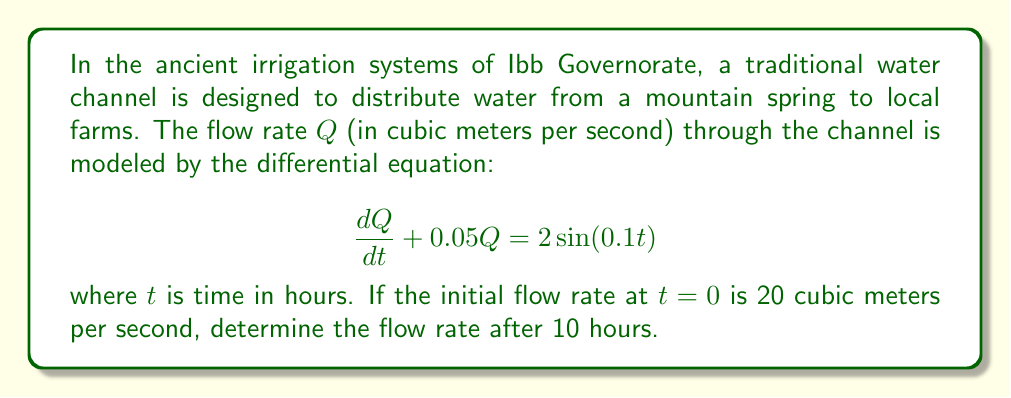Show me your answer to this math problem. To solve this first-order linear differential equation, we'll use the integrating factor method:

1) The equation is in the form $\frac{dQ}{dt} + PQ = f(t)$, where $P = 0.05$ and $f(t) = 2\sin(0.1t)$.

2) The integrating factor is $\mu(t) = e^{\int P dt} = e^{0.05t}$.

3) Multiply both sides of the equation by $\mu(t)$:

   $$e^{0.05t}\frac{dQ}{dt} + 0.05e^{0.05t}Q = 2e^{0.05t}\sin(0.1t)$$

4) The left side is now the derivative of $e^{0.05t}Q$:

   $$\frac{d}{dt}(e^{0.05t}Q) = 2e^{0.05t}\sin(0.1t)$$

5) Integrate both sides:

   $$e^{0.05t}Q = \int 2e^{0.05t}\sin(0.1t)dt$$

6) Solve the integral using integration by parts:

   $$e^{0.05t}Q = 2e^{0.05t}(\frac{5\sin(0.1t) - 10\cos(0.1t)}{1.25}) + C$$

7) Divide both sides by $e^{0.05t}$:

   $$Q = \frac{10(\sin(0.1t) - 2\cos(0.1t))}{1.25} + Ce^{-0.05t}$$

8) Use the initial condition $Q(0) = 20$ to find $C$:

   $$20 = \frac{10(-2)}{1.25} + C$$
   $$C = 20 + 16 = 36$$

9) The complete solution is:

   $$Q = \frac{10(\sin(0.1t) - 2\cos(0.1t))}{1.25} + 36e^{-0.05t}$$

10) To find $Q$ at $t=10$, substitute $t=10$ into this equation:

    $$Q(10) = \frac{10(\sin(1) - 2\cos(1))}{1.25} + 36e^{-0.5}$$
Answer: $Q(10) \approx 13.95$ cubic meters per second 